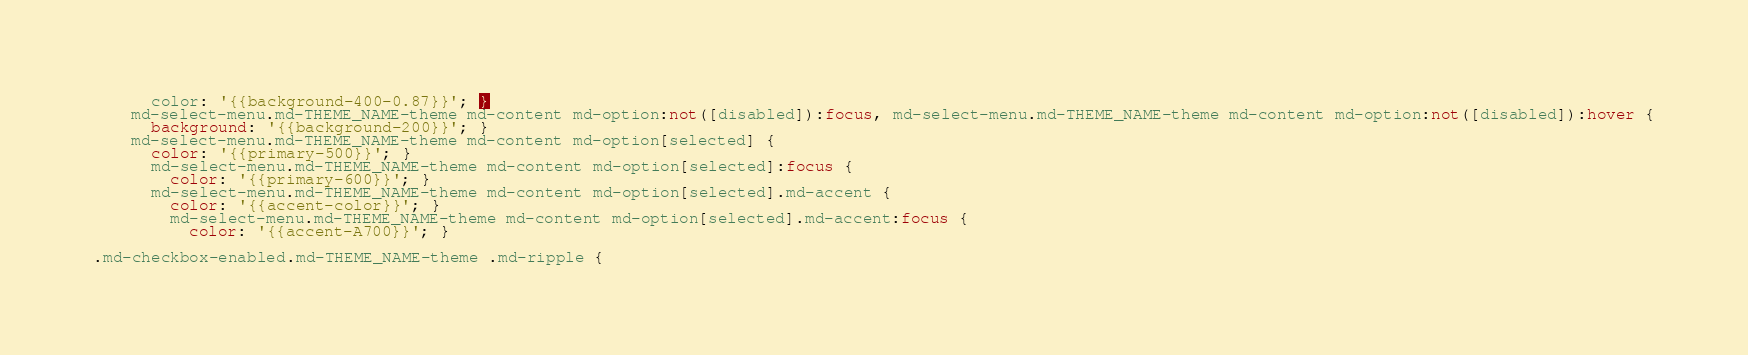Convert code to text. <code><loc_0><loc_0><loc_500><loc_500><_CSS_>      color: '{{background-400-0.87}}'; }
    md-select-menu.md-THEME_NAME-theme md-content md-option:not([disabled]):focus, md-select-menu.md-THEME_NAME-theme md-content md-option:not([disabled]):hover {
      background: '{{background-200}}'; }
    md-select-menu.md-THEME_NAME-theme md-content md-option[selected] {
      color: '{{primary-500}}'; }
      md-select-menu.md-THEME_NAME-theme md-content md-option[selected]:focus {
        color: '{{primary-600}}'; }
      md-select-menu.md-THEME_NAME-theme md-content md-option[selected].md-accent {
        color: '{{accent-color}}'; }
        md-select-menu.md-THEME_NAME-theme md-content md-option[selected].md-accent:focus {
          color: '{{accent-A700}}'; }

.md-checkbox-enabled.md-THEME_NAME-theme .md-ripple {</code> 